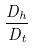<formula> <loc_0><loc_0><loc_500><loc_500>\frac { D _ { h } } { D _ { t } }</formula> 